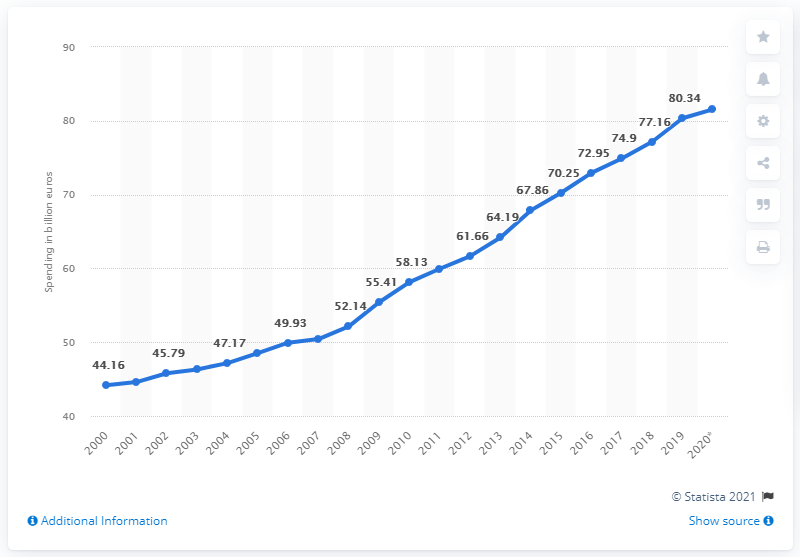Draw attention to some important aspects in this diagram. In 2020, the value of hospital treatments covered by statutory health insurance in Germany was 81.54. In the previous year, the amount of hospital treatments covered by statutory health insurance in Germany was 80.34. 